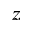<formula> <loc_0><loc_0><loc_500><loc_500>z</formula> 